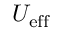<formula> <loc_0><loc_0><loc_500><loc_500>U _ { e f f }</formula> 